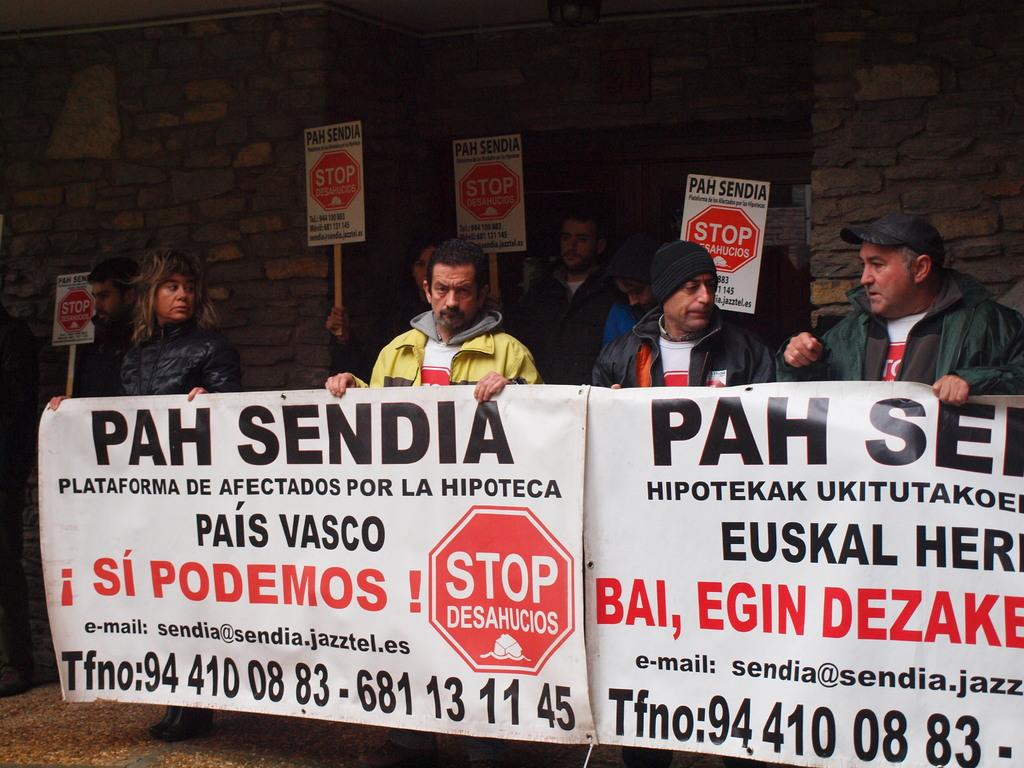How many people are holding banners in the front of the image? There are four persons standing and holding banners in the front of the image. What are the people in the background of the image holding? The people in the background of the image are holding placards. What can be seen behind the people in the image? There is a wall visible in the image. What type of badge is being worn by the person in the image? There is no badge visible on any person in the image. What color is the gold object being held by the person in the image? There is no gold object present in the image. 